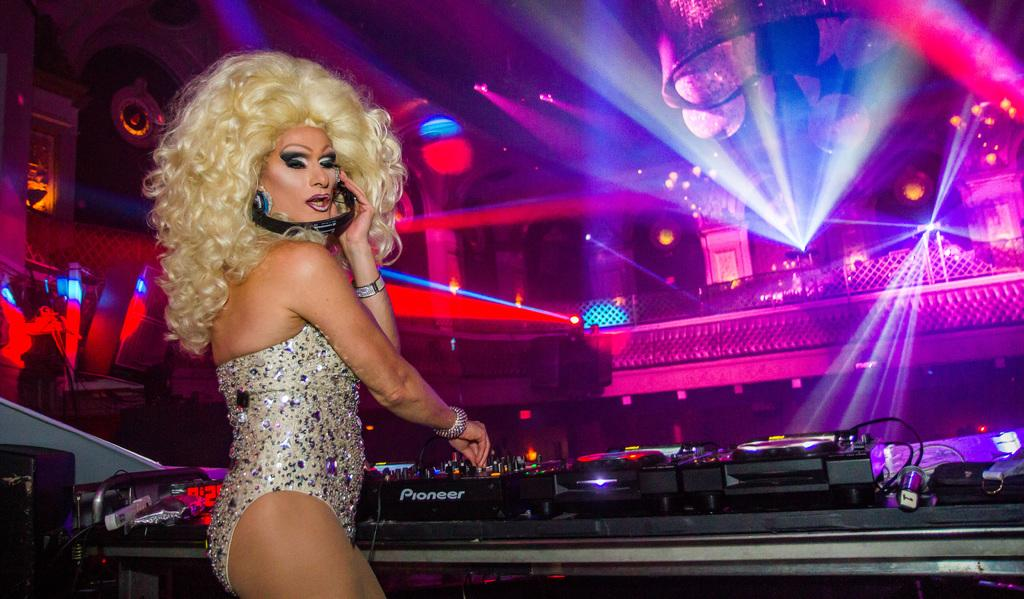What is the main subject of the image? There is a person in the image. Can you describe the person's attire? The person is wearing clothes. What can be seen at the bottom of the image? There is a musical equipment at the bottom of the image. What is located in the middle of the image? There are some lights in the middle of the image. What type of brass instruments can be seen in the image? There is no brass instrument present in the image. How many cats are visible in the image? There are no cats present in the image. 